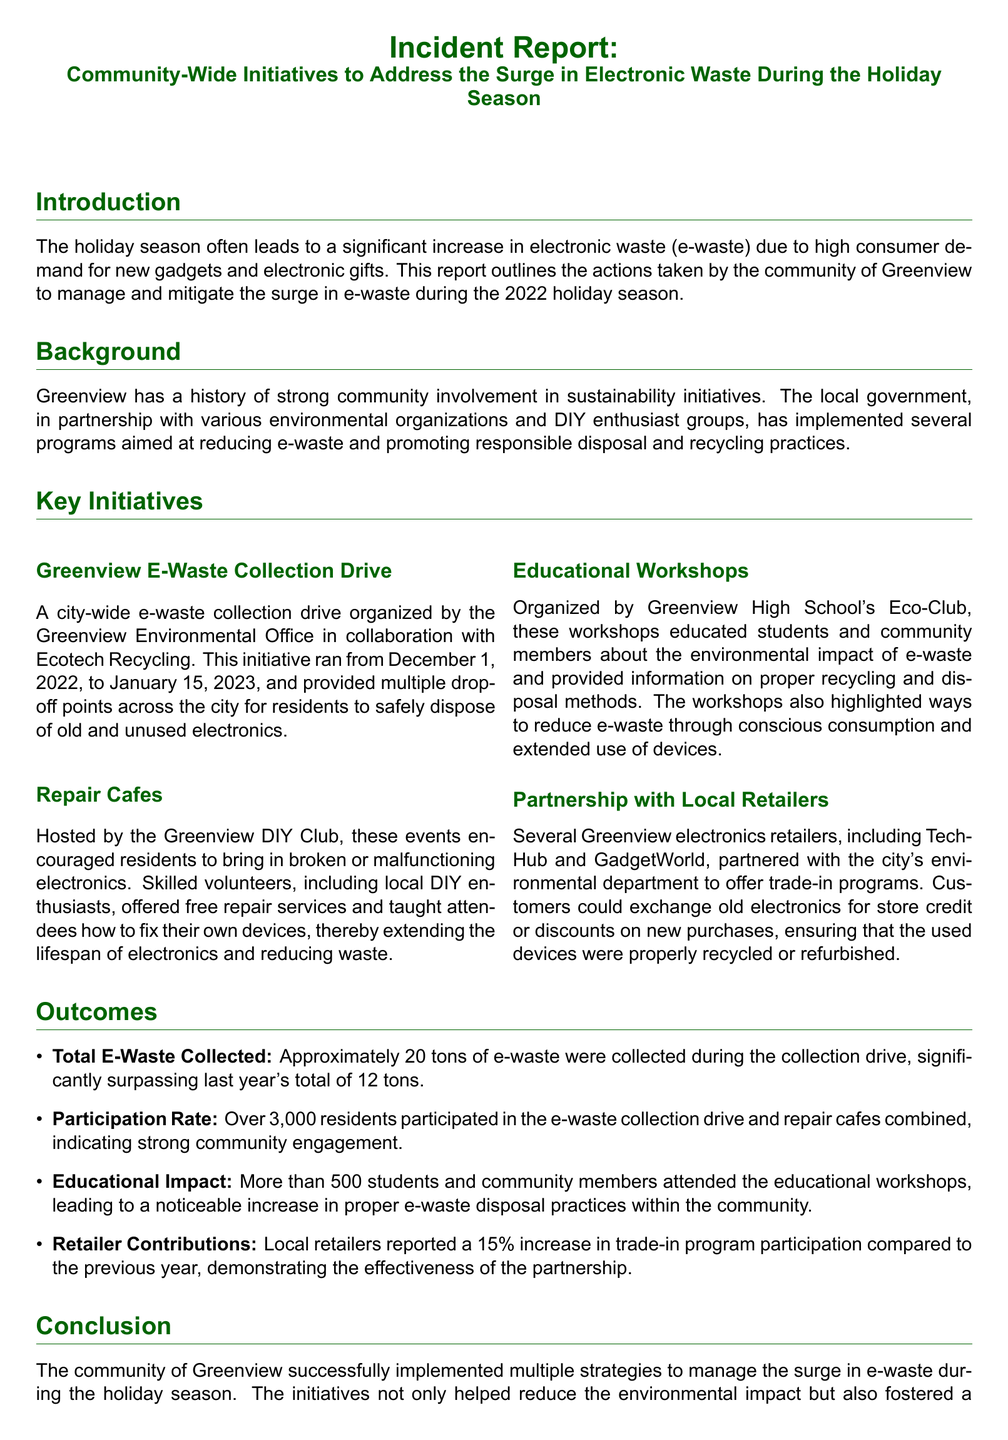What is the total e-waste collected? The total e-waste collected during the collection drive is approximately 20 tons, as stated in the outcomes section of the report.
Answer: 20 tons What dates did the e-waste collection drive span? The collection drive was organized from December 1, 2022, to January 15, 2023, which is mentioned under the key initiatives.
Answer: December 1, 2022, to January 15, 2023 How many residents participated in the initiatives? The report indicates that over 3,000 residents participated in the e-waste collection drive and repair cafes combined.
Answer: Over 3,000 residents Which organization hosted the repair cafes? The repair cafes were hosted by the Greenview DIY Club, as mentioned in the key initiatives section.
Answer: Greenview DIY Club What percentage increase did local retailers report in trade-in program participation? The local retailers reported a 15% increase in trade-in program participation compared to the previous year, as noted in the outcomes section.
Answer: 15% What was the educational impact in terms of attendance? More than 500 students and community members attended the educational workshops, which is specified in the outcomes section.
Answer: More than 500 What is the primary focus of the educational workshops? The educational workshops focused on educating the community about the environmental impact of e-waste and proper disposal methods, as outlined in the key initiatives.
Answer: Environmental impact of e-waste What community initiative is aimed at extending the lifespan of electronics? The Repair Cafes initiative is aimed at extending the lifespan of electronics through repair services, which is detailed in the key initiatives.
Answer: Repair Cafes 